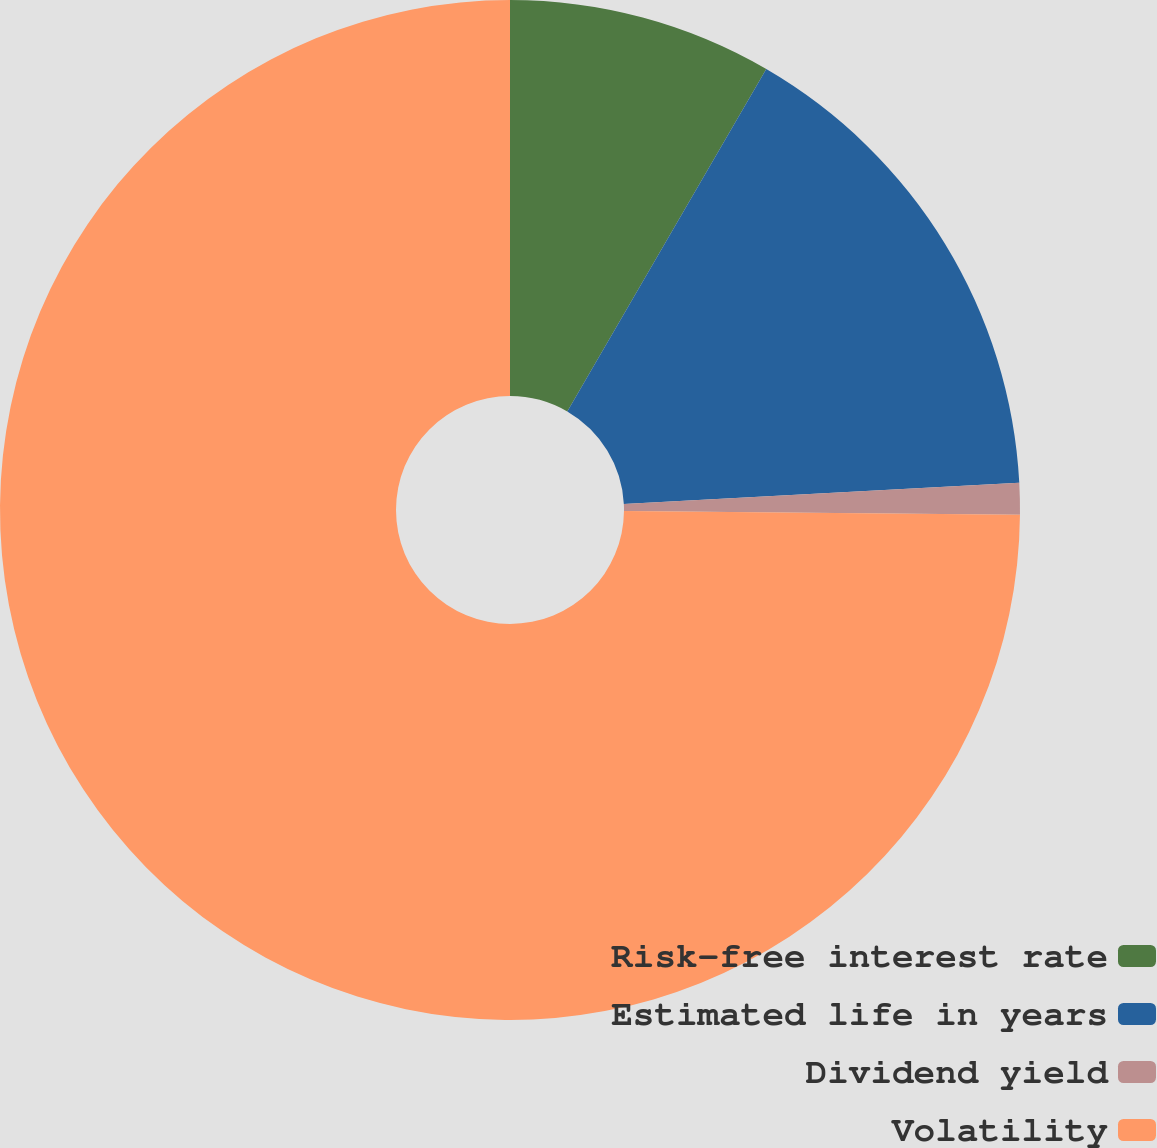<chart> <loc_0><loc_0><loc_500><loc_500><pie_chart><fcel>Risk-free interest rate<fcel>Estimated life in years<fcel>Dividend yield<fcel>Volatility<nl><fcel>8.38%<fcel>15.77%<fcel>1.0%<fcel>74.85%<nl></chart> 